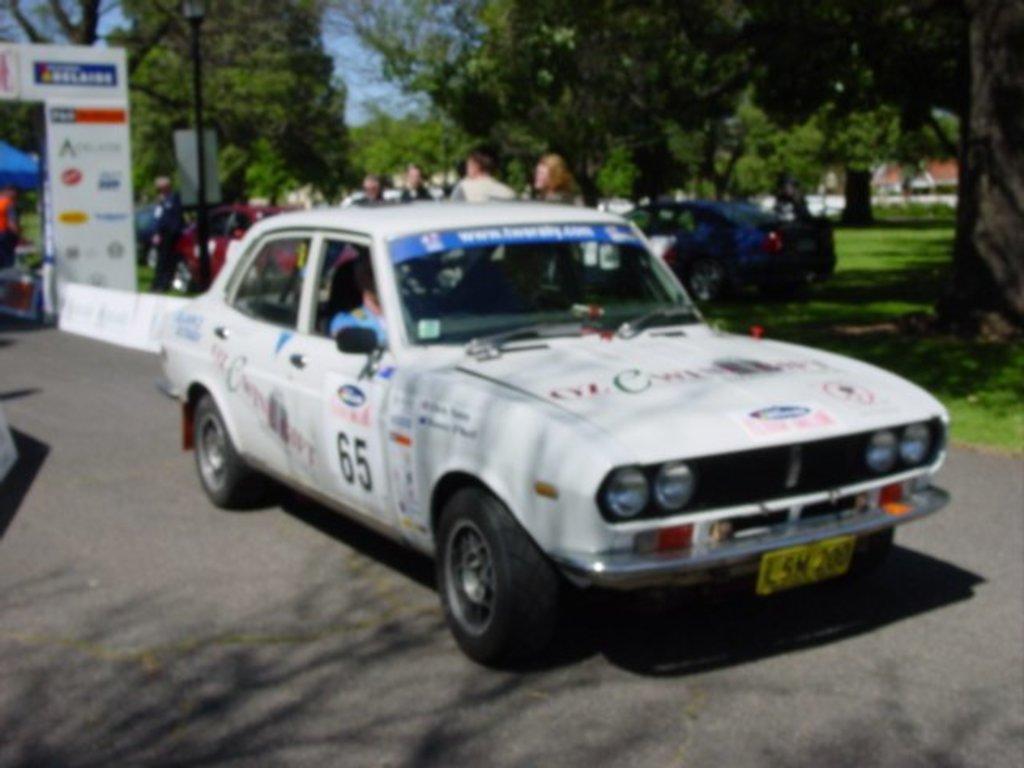In one or two sentences, can you explain what this image depicts? In front of the image on the road there is a car with text and stickers on it. Behind the car there is an arch shaped banners with logos. In the background there are few people, cars and also there is a pole. And there are many trees in the background. 